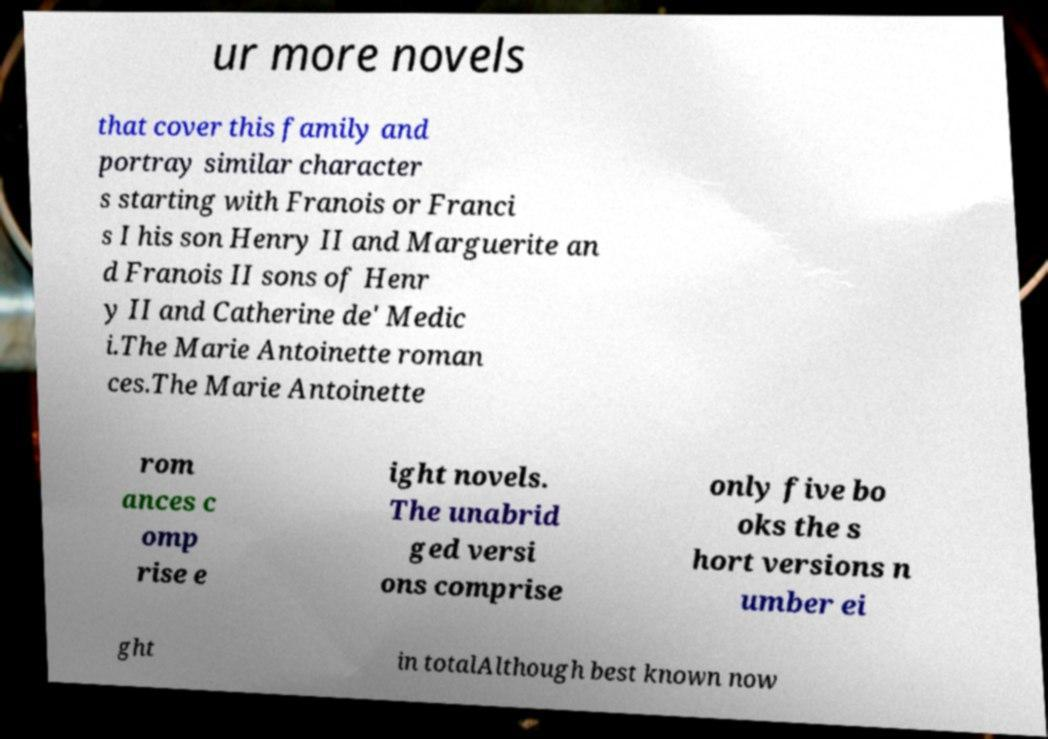Please identify and transcribe the text found in this image. ur more novels that cover this family and portray similar character s starting with Franois or Franci s I his son Henry II and Marguerite an d Franois II sons of Henr y II and Catherine de' Medic i.The Marie Antoinette roman ces.The Marie Antoinette rom ances c omp rise e ight novels. The unabrid ged versi ons comprise only five bo oks the s hort versions n umber ei ght in totalAlthough best known now 